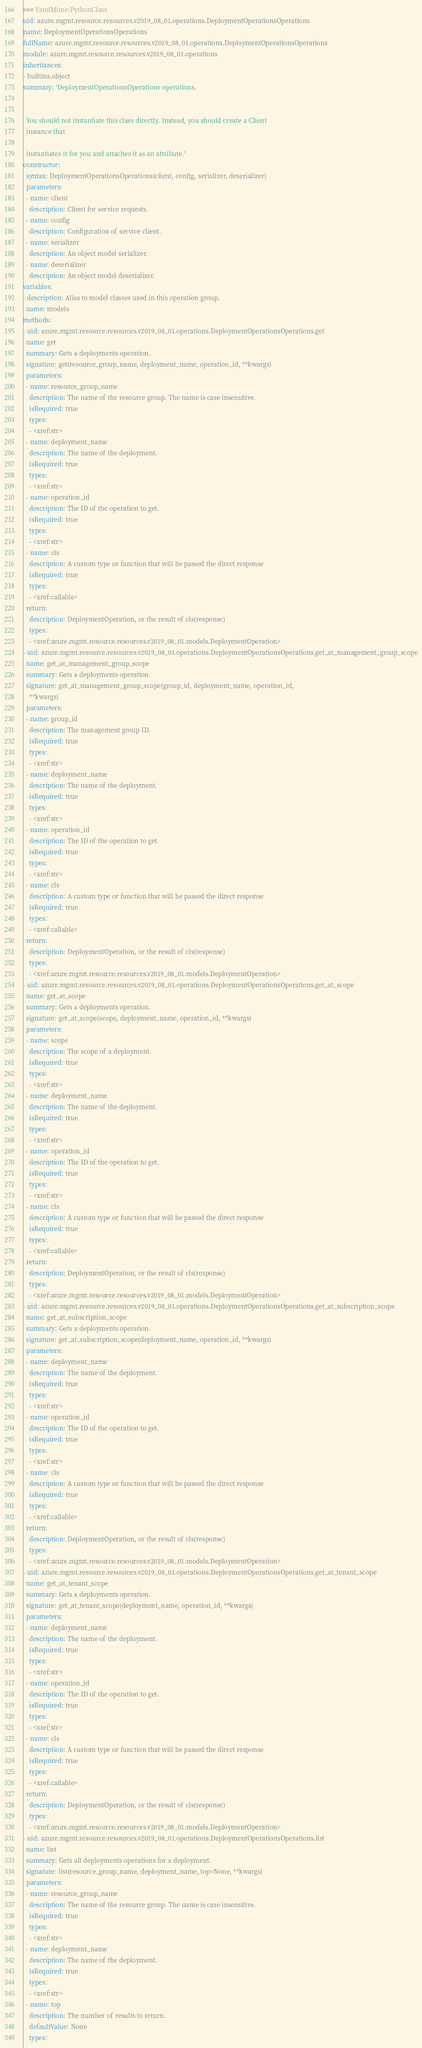Convert code to text. <code><loc_0><loc_0><loc_500><loc_500><_YAML_>### YamlMime:PythonClass
uid: azure.mgmt.resource.resources.v2019_08_01.operations.DeploymentOperationsOperations
name: DeploymentOperationsOperations
fullName: azure.mgmt.resource.resources.v2019_08_01.operations.DeploymentOperationsOperations
module: azure.mgmt.resource.resources.v2019_08_01.operations
inheritances:
- builtins.object
summary: 'DeploymentOperationsOperations operations.


  You should not instantiate this class directly. Instead, you should create a Client
  instance that

  instantiates it for you and attaches it as an attribute.'
constructor:
  syntax: DeploymentOperationsOperations(client, config, serializer, deserializer)
  parameters:
  - name: client
    description: Client for service requests.
  - name: config
    description: Configuration of service client.
  - name: serializer
    description: An object model serializer.
  - name: deserializer
    description: An object model deserializer.
variables:
- description: Alias to model classes used in this operation group.
  name: models
methods:
- uid: azure.mgmt.resource.resources.v2019_08_01.operations.DeploymentOperationsOperations.get
  name: get
  summary: Gets a deployments operation.
  signature: get(resource_group_name, deployment_name, operation_id, **kwargs)
  parameters:
  - name: resource_group_name
    description: The name of the resource group. The name is case insensitive.
    isRequired: true
    types:
    - <xref:str>
  - name: deployment_name
    description: The name of the deployment.
    isRequired: true
    types:
    - <xref:str>
  - name: operation_id
    description: The ID of the operation to get.
    isRequired: true
    types:
    - <xref:str>
  - name: cls
    description: A custom type or function that will be passed the direct response
    isRequired: true
    types:
    - <xref:callable>
  return:
    description: DeploymentOperation, or the result of cls(response)
    types:
    - <xref:azure.mgmt.resource.resources.v2019_08_01.models.DeploymentOperation>
- uid: azure.mgmt.resource.resources.v2019_08_01.operations.DeploymentOperationsOperations.get_at_management_group_scope
  name: get_at_management_group_scope
  summary: Gets a deployments operation.
  signature: get_at_management_group_scope(group_id, deployment_name, operation_id,
    **kwargs)
  parameters:
  - name: group_id
    description: The management group ID.
    isRequired: true
    types:
    - <xref:str>
  - name: deployment_name
    description: The name of the deployment.
    isRequired: true
    types:
    - <xref:str>
  - name: operation_id
    description: The ID of the operation to get.
    isRequired: true
    types:
    - <xref:str>
  - name: cls
    description: A custom type or function that will be passed the direct response
    isRequired: true
    types:
    - <xref:callable>
  return:
    description: DeploymentOperation, or the result of cls(response)
    types:
    - <xref:azure.mgmt.resource.resources.v2019_08_01.models.DeploymentOperation>
- uid: azure.mgmt.resource.resources.v2019_08_01.operations.DeploymentOperationsOperations.get_at_scope
  name: get_at_scope
  summary: Gets a deployments operation.
  signature: get_at_scope(scope, deployment_name, operation_id, **kwargs)
  parameters:
  - name: scope
    description: The scope of a deployment.
    isRequired: true
    types:
    - <xref:str>
  - name: deployment_name
    description: The name of the deployment.
    isRequired: true
    types:
    - <xref:str>
  - name: operation_id
    description: The ID of the operation to get.
    isRequired: true
    types:
    - <xref:str>
  - name: cls
    description: A custom type or function that will be passed the direct response
    isRequired: true
    types:
    - <xref:callable>
  return:
    description: DeploymentOperation, or the result of cls(response)
    types:
    - <xref:azure.mgmt.resource.resources.v2019_08_01.models.DeploymentOperation>
- uid: azure.mgmt.resource.resources.v2019_08_01.operations.DeploymentOperationsOperations.get_at_subscription_scope
  name: get_at_subscription_scope
  summary: Gets a deployments operation.
  signature: get_at_subscription_scope(deployment_name, operation_id, **kwargs)
  parameters:
  - name: deployment_name
    description: The name of the deployment.
    isRequired: true
    types:
    - <xref:str>
  - name: operation_id
    description: The ID of the operation to get.
    isRequired: true
    types:
    - <xref:str>
  - name: cls
    description: A custom type or function that will be passed the direct response
    isRequired: true
    types:
    - <xref:callable>
  return:
    description: DeploymentOperation, or the result of cls(response)
    types:
    - <xref:azure.mgmt.resource.resources.v2019_08_01.models.DeploymentOperation>
- uid: azure.mgmt.resource.resources.v2019_08_01.operations.DeploymentOperationsOperations.get_at_tenant_scope
  name: get_at_tenant_scope
  summary: Gets a deployments operation.
  signature: get_at_tenant_scope(deployment_name, operation_id, **kwargs)
  parameters:
  - name: deployment_name
    description: The name of the deployment.
    isRequired: true
    types:
    - <xref:str>
  - name: operation_id
    description: The ID of the operation to get.
    isRequired: true
    types:
    - <xref:str>
  - name: cls
    description: A custom type or function that will be passed the direct response
    isRequired: true
    types:
    - <xref:callable>
  return:
    description: DeploymentOperation, or the result of cls(response)
    types:
    - <xref:azure.mgmt.resource.resources.v2019_08_01.models.DeploymentOperation>
- uid: azure.mgmt.resource.resources.v2019_08_01.operations.DeploymentOperationsOperations.list
  name: list
  summary: Gets all deployments operations for a deployment.
  signature: list(resource_group_name, deployment_name, top=None, **kwargs)
  parameters:
  - name: resource_group_name
    description: The name of the resource group. The name is case insensitive.
    isRequired: true
    types:
    - <xref:str>
  - name: deployment_name
    description: The name of the deployment.
    isRequired: true
    types:
    - <xref:str>
  - name: top
    description: The number of results to return.
    defaultValue: None
    types:</code> 